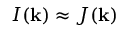Convert formula to latex. <formula><loc_0><loc_0><loc_500><loc_500>I ( k ) \approx J ( k )</formula> 